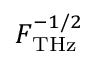<formula> <loc_0><loc_0><loc_500><loc_500>F _ { T H z } ^ { - 1 / 2 }</formula> 